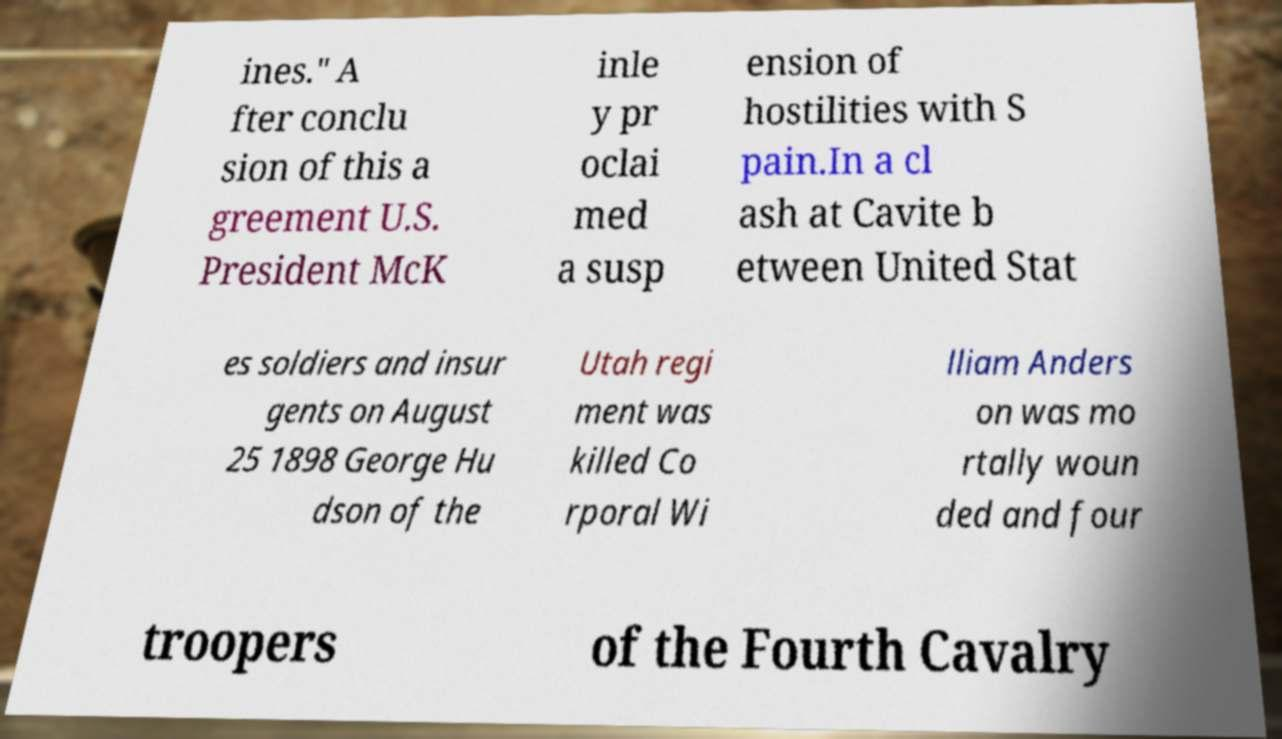Can you accurately transcribe the text from the provided image for me? ines." A fter conclu sion of this a greement U.S. President McK inle y pr oclai med a susp ension of hostilities with S pain.In a cl ash at Cavite b etween United Stat es soldiers and insur gents on August 25 1898 George Hu dson of the Utah regi ment was killed Co rporal Wi lliam Anders on was mo rtally woun ded and four troopers of the Fourth Cavalry 